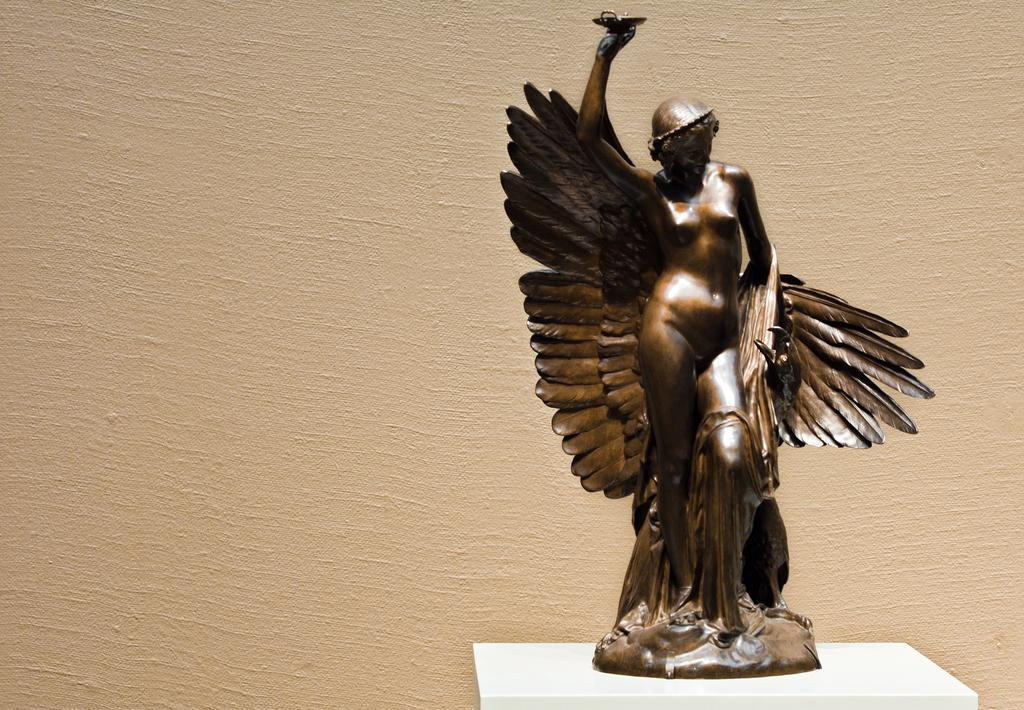What is the main subject of the image? There is a lady statue in the image. Where is the lady statue located? The lady statue is on a white table. What can be seen in the background of the image? There is a wall in the background of the image. What type of rod is the lady statue holding in the image? There is no rod present in the image; the lady statue is not holding anything. What government policy is being discussed in the image? There is no discussion of government policy in the image; it features a lady statue on a white table with a wall in the background. 